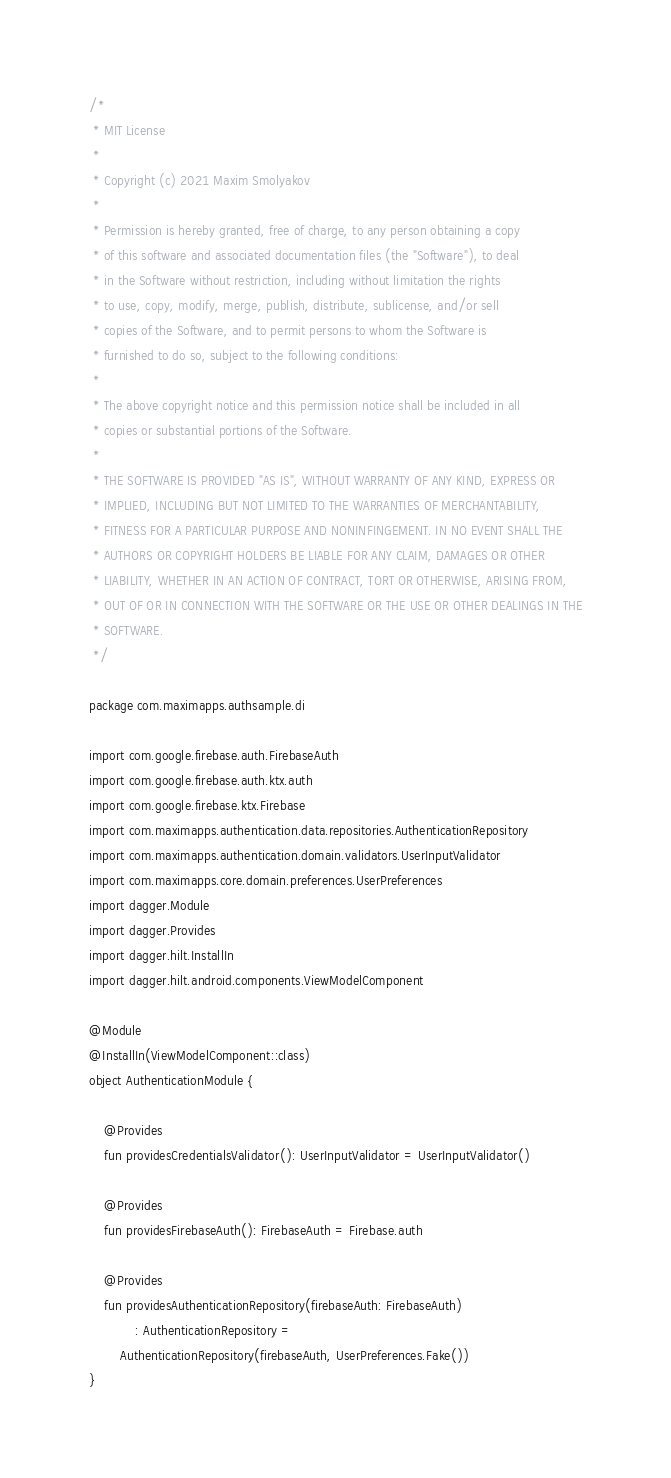Convert code to text. <code><loc_0><loc_0><loc_500><loc_500><_Kotlin_>/*
 * MIT License
 *
 * Copyright (c) 2021 Maxim Smolyakov
 *
 * Permission is hereby granted, free of charge, to any person obtaining a copy
 * of this software and associated documentation files (the "Software"), to deal
 * in the Software without restriction, including without limitation the rights
 * to use, copy, modify, merge, publish, distribute, sublicense, and/or sell
 * copies of the Software, and to permit persons to whom the Software is
 * furnished to do so, subject to the following conditions:
 *
 * The above copyright notice and this permission notice shall be included in all
 * copies or substantial portions of the Software.
 *
 * THE SOFTWARE IS PROVIDED "AS IS", WITHOUT WARRANTY OF ANY KIND, EXPRESS OR
 * IMPLIED, INCLUDING BUT NOT LIMITED TO THE WARRANTIES OF MERCHANTABILITY,
 * FITNESS FOR A PARTICULAR PURPOSE AND NONINFINGEMENT. IN NO EVENT SHALL THE
 * AUTHORS OR COPYRIGHT HOLDERS BE LIABLE FOR ANY CLAIM, DAMAGES OR OTHER
 * LIABILITY, WHETHER IN AN ACTION OF CONTRACT, TORT OR OTHERWISE, ARISING FROM,
 * OUT OF OR IN CONNECTION WITH THE SOFTWARE OR THE USE OR OTHER DEALINGS IN THE
 * SOFTWARE.
 */

package com.maximapps.authsample.di

import com.google.firebase.auth.FirebaseAuth
import com.google.firebase.auth.ktx.auth
import com.google.firebase.ktx.Firebase
import com.maximapps.authentication.data.repositories.AuthenticationRepository
import com.maximapps.authentication.domain.validators.UserInputValidator
import com.maximapps.core.domain.preferences.UserPreferences
import dagger.Module
import dagger.Provides
import dagger.hilt.InstallIn
import dagger.hilt.android.components.ViewModelComponent

@Module
@InstallIn(ViewModelComponent::class)
object AuthenticationModule {

    @Provides
    fun providesCredentialsValidator(): UserInputValidator = UserInputValidator()

    @Provides
    fun providesFirebaseAuth(): FirebaseAuth = Firebase.auth

    @Provides
    fun providesAuthenticationRepository(firebaseAuth: FirebaseAuth)
            : AuthenticationRepository =
        AuthenticationRepository(firebaseAuth, UserPreferences.Fake())
}
</code> 